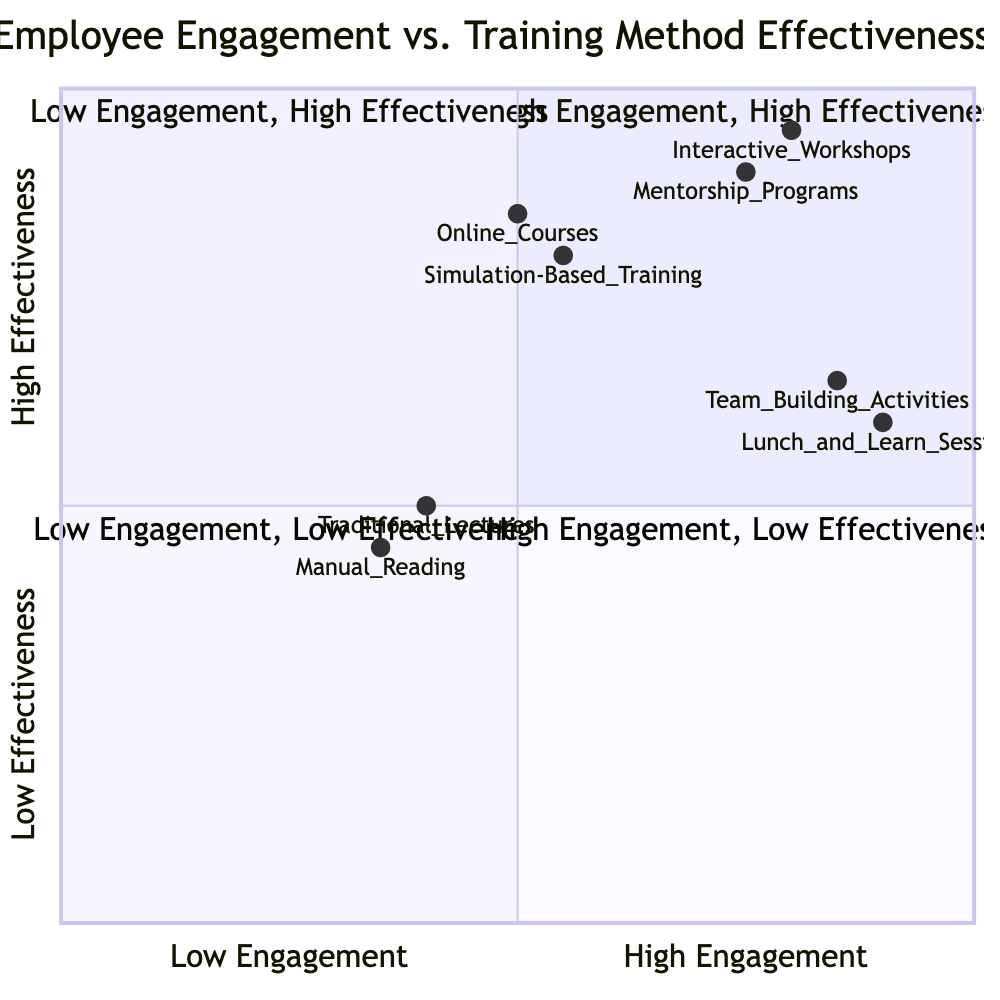What training method has the highest satisfaction level? To find the training method with the highest satisfaction, I examine all the elements in the quadrants for their satisfaction levels. The maximum satisfaction level is 95% associated with "Interactive Workshops."
Answer: Interactive Workshops How many training methods are in the "Low Engagement, Low Effectiveness" quadrant? I check the "Low Engagement, Low Effectiveness" quadrant and see it contains two training methods: "Traditional Lectures" and "Manual Reading." Therefore, the count is 2.
Answer: 2 Which quadrant has the training method with the lowest participation level? I need to check each quadrant for participation levels. The lowest participation level observed is 35%, which is related to "Manual Reading" in the "Low Engagement, Low Effectiveness" quadrant.
Answer: Low Engagement, Low Effectiveness What is the participation level of "Team Building Activities"? I locate "Team Building Activities" in the diagram and find its participation level listed as 85%.
Answer: 85% Which training method has the highest engagement level? I analyze the training methods in the "High Engagement" quadrants. "Team Building Activities" has a participation level of 85%, while "Interactive Workshops" has 80%. "Interactive Workshops" has the highest engagement level in its respective quadrant compared to its peers.
Answer: Team Building Activities In the "High Engagement, High Effectiveness" quadrant, how many training methods are listed? I glance at the "High Engagement, High Effectiveness" quadrant and count the mentioned training methods: "Interactive Workshops" and "Mentorship Programs," which totals to 2.
Answer: 2 Which method is more effective: "Online Courses" or "Simulation-Based Training"? By reviewing the satisfaction levels in the "Low Engagement, High Effectiveness" quadrant, "Online Courses" has a satisfaction level of 85% while "Simulation-Based Training" has 80%. Thus, "Online Courses" is more effective based on the given metrics.
Answer: Online Courses What is the satisfaction level of "Lunch and Learn Sessions"? I identify "Lunch and Learn Sessions" in the "High Engagement, Low Effectiveness" quadrant and find its satisfaction level is 60%.
Answer: 60% 